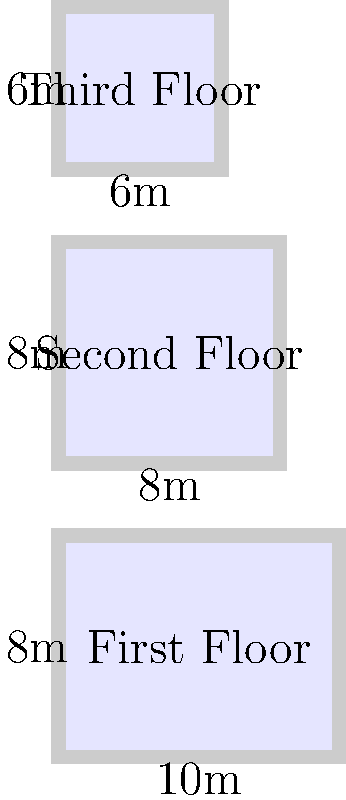As a mortgage application assessor, you need to calculate the total square footage of a multi-level house. The house has three floors with irregular dimensions:
1. First floor: 10m x 8m
2. Second floor: 8m x 8m
3. Third floor: 6m x 6m

What is the total square footage of the house, rounded to the nearest square foot? (Use 1 m² = 10.764 ft²) To calculate the total square footage, we need to:
1. Calculate the area of each floor in square meters
2. Sum up the areas
3. Convert the total area from square meters to square feet
4. Round the result to the nearest square foot

Step 1: Calculate area of each floor
- First floor: $A_1 = 10 \text{ m} \times 8 \text{ m} = 80 \text{ m}^2$
- Second floor: $A_2 = 8 \text{ m} \times 8 \text{ m} = 64 \text{ m}^2$
- Third floor: $A_3 = 6 \text{ m} \times 6 \text{ m} = 36 \text{ m}^2$

Step 2: Sum up the areas
$A_{\text{total}} = A_1 + A_2 + A_3 = 80 \text{ m}^2 + 64 \text{ m}^2 + 36 \text{ m}^2 = 180 \text{ m}^2$

Step 3: Convert to square feet
$180 \text{ m}^2 \times 10.764 \text{ ft}^2/\text{m}^2 = 1,937.52 \text{ ft}^2$

Step 4: Round to the nearest square foot
$1,937.52 \text{ ft}^2 \approx 1,938 \text{ ft}^2$
Answer: 1,938 ft² 